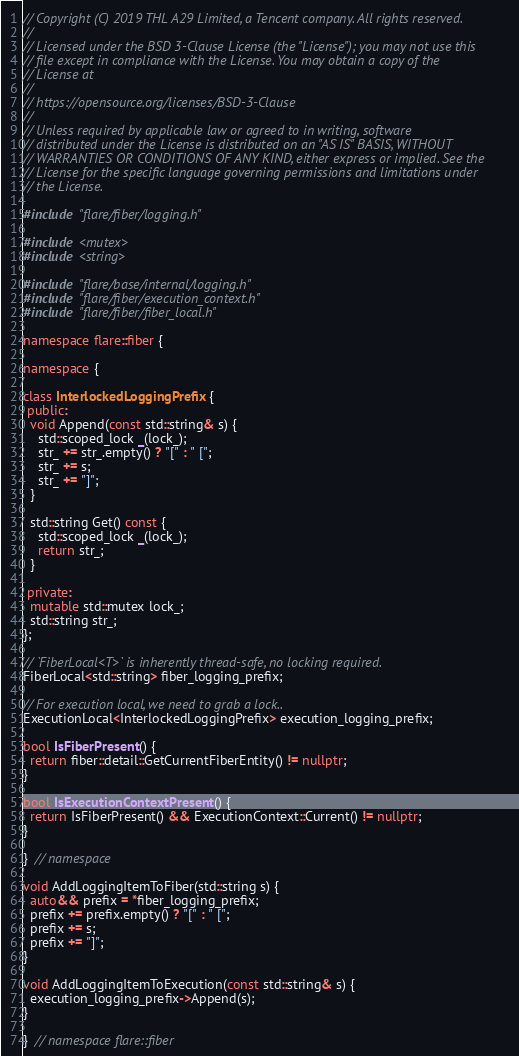<code> <loc_0><loc_0><loc_500><loc_500><_C++_>// Copyright (C) 2019 THL A29 Limited, a Tencent company. All rights reserved.
//
// Licensed under the BSD 3-Clause License (the "License"); you may not use this
// file except in compliance with the License. You may obtain a copy of the
// License at
//
// https://opensource.org/licenses/BSD-3-Clause
//
// Unless required by applicable law or agreed to in writing, software
// distributed under the License is distributed on an "AS IS" BASIS, WITHOUT
// WARRANTIES OR CONDITIONS OF ANY KIND, either express or implied. See the
// License for the specific language governing permissions and limitations under
// the License.

#include "flare/fiber/logging.h"

#include <mutex>
#include <string>

#include "flare/base/internal/logging.h"
#include "flare/fiber/execution_context.h"
#include "flare/fiber/fiber_local.h"

namespace flare::fiber {

namespace {

class InterlockedLoggingPrefix {
 public:
  void Append(const std::string& s) {
    std::scoped_lock _(lock_);
    str_ += str_.empty() ? "[" : " [";
    str_ += s;
    str_ += "]";
  }

  std::string Get() const {
    std::scoped_lock _(lock_);
    return str_;
  }

 private:
  mutable std::mutex lock_;
  std::string str_;
};

// `FiberLocal<T>` is inherently thread-safe, no locking required.
FiberLocal<std::string> fiber_logging_prefix;

// For execution local, we need to grab a lock..
ExecutionLocal<InterlockedLoggingPrefix> execution_logging_prefix;

bool IsFiberPresent() {
  return fiber::detail::GetCurrentFiberEntity() != nullptr;
}

bool IsExecutionContextPresent() {
  return IsFiberPresent() && ExecutionContext::Current() != nullptr;
}

}  // namespace

void AddLoggingItemToFiber(std::string s) {
  auto&& prefix = *fiber_logging_prefix;
  prefix += prefix.empty() ? "[" : " [";
  prefix += s;
  prefix += "]";
}

void AddLoggingItemToExecution(const std::string& s) {
  execution_logging_prefix->Append(s);
}

}  // namespace flare::fiber
</code> 